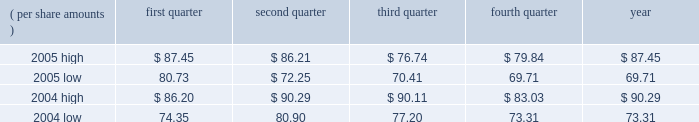Liabilities and related insurance receivables where applicable , or make such estimates for matters previously not susceptible of reasonable estimates , such as a significant judicial ruling or judgment , significant settlement , significant regulatory development or changes in applicable law .
A future adverse ruling , settlement or unfavorable development could result in future charges that could have a material adverse effect on the company 2019s results of operations or cash flows in any particular period .
A specific factor that could increase the company 2019s estimate of its future asbestos-related liabilities is the pending congressional consideration of legislation to reform asbestos- related litigation and pertinent information derived from that process .
For a more detailed discussion of the legal proceedings involving the company and associated accounting estimates , see the discussion in note 11 to the consolidated financial statements of this annual report on form 10-k .
Item 1b .
Unresolved staff comments .
Item 2 .
Properties .
3m 2019s general offices , corporate research laboratories , and certain division laboratories are located in st .
Paul , minnesota .
In the united states , 3m has 15 sales offices in 12 states and operates 59 manufacturing facilities in 23 states .
Internationally , 3m has 173 sales offices .
The company operates 80 manufacturing and converting facilities in 29 countries outside the united states .
3m owns substantially all of its physical properties .
3m 2019s physical facilities are highly suitable for the purposes for which they were designed .
Because 3m is a global enterprise characterized by substantial intersegment cooperation , properties are often used by multiple business segments .
Item 3 .
Legal proceedings .
Discussion of legal matters is incorporated by reference from part ii , item 8 , note 11 , 201ccommitments and contingencies 201d , of this document , and should be considered an integral part of part i , item 3 , 201clegal proceedings 201d .
Item 4 .
Submission of matters to a vote of security holders .
None in the quarter ended december 31 , 2005 .
Part ii item 5 .
Market for registrant 2019s common equity , related stockholder matters and issuer purchases of equity securities .
Equity compensation plans 2019 information is incorporated by reference from part iii , item 12 , security ownership of certain beneficial owners and management , of this document , and should be considered an integral part of item 5 .
At january 31 , 2006 , there were approximately 125823 shareholders of record .
3m 2019s stock is listed on the new york stock exchange , inc .
( nyse ) , pacific exchange , inc. , chicago stock exchange , inc. , and the swx swiss exchange .
Cash dividends declared and paid totaled $ .42 per share for each quarter of 2005 , and $ .36 per share for each quarter of 2004 .
Stock price comparisons follow : stock price comparisons ( nyse composite transactions ) ( per share amounts ) quarter second quarter quarter fourth quarter year .

In 2005 what was the percentage difference in the year end high and low? 
Computations: ((87.45 - 69.71) / 69.71)
Answer: 0.25448. 